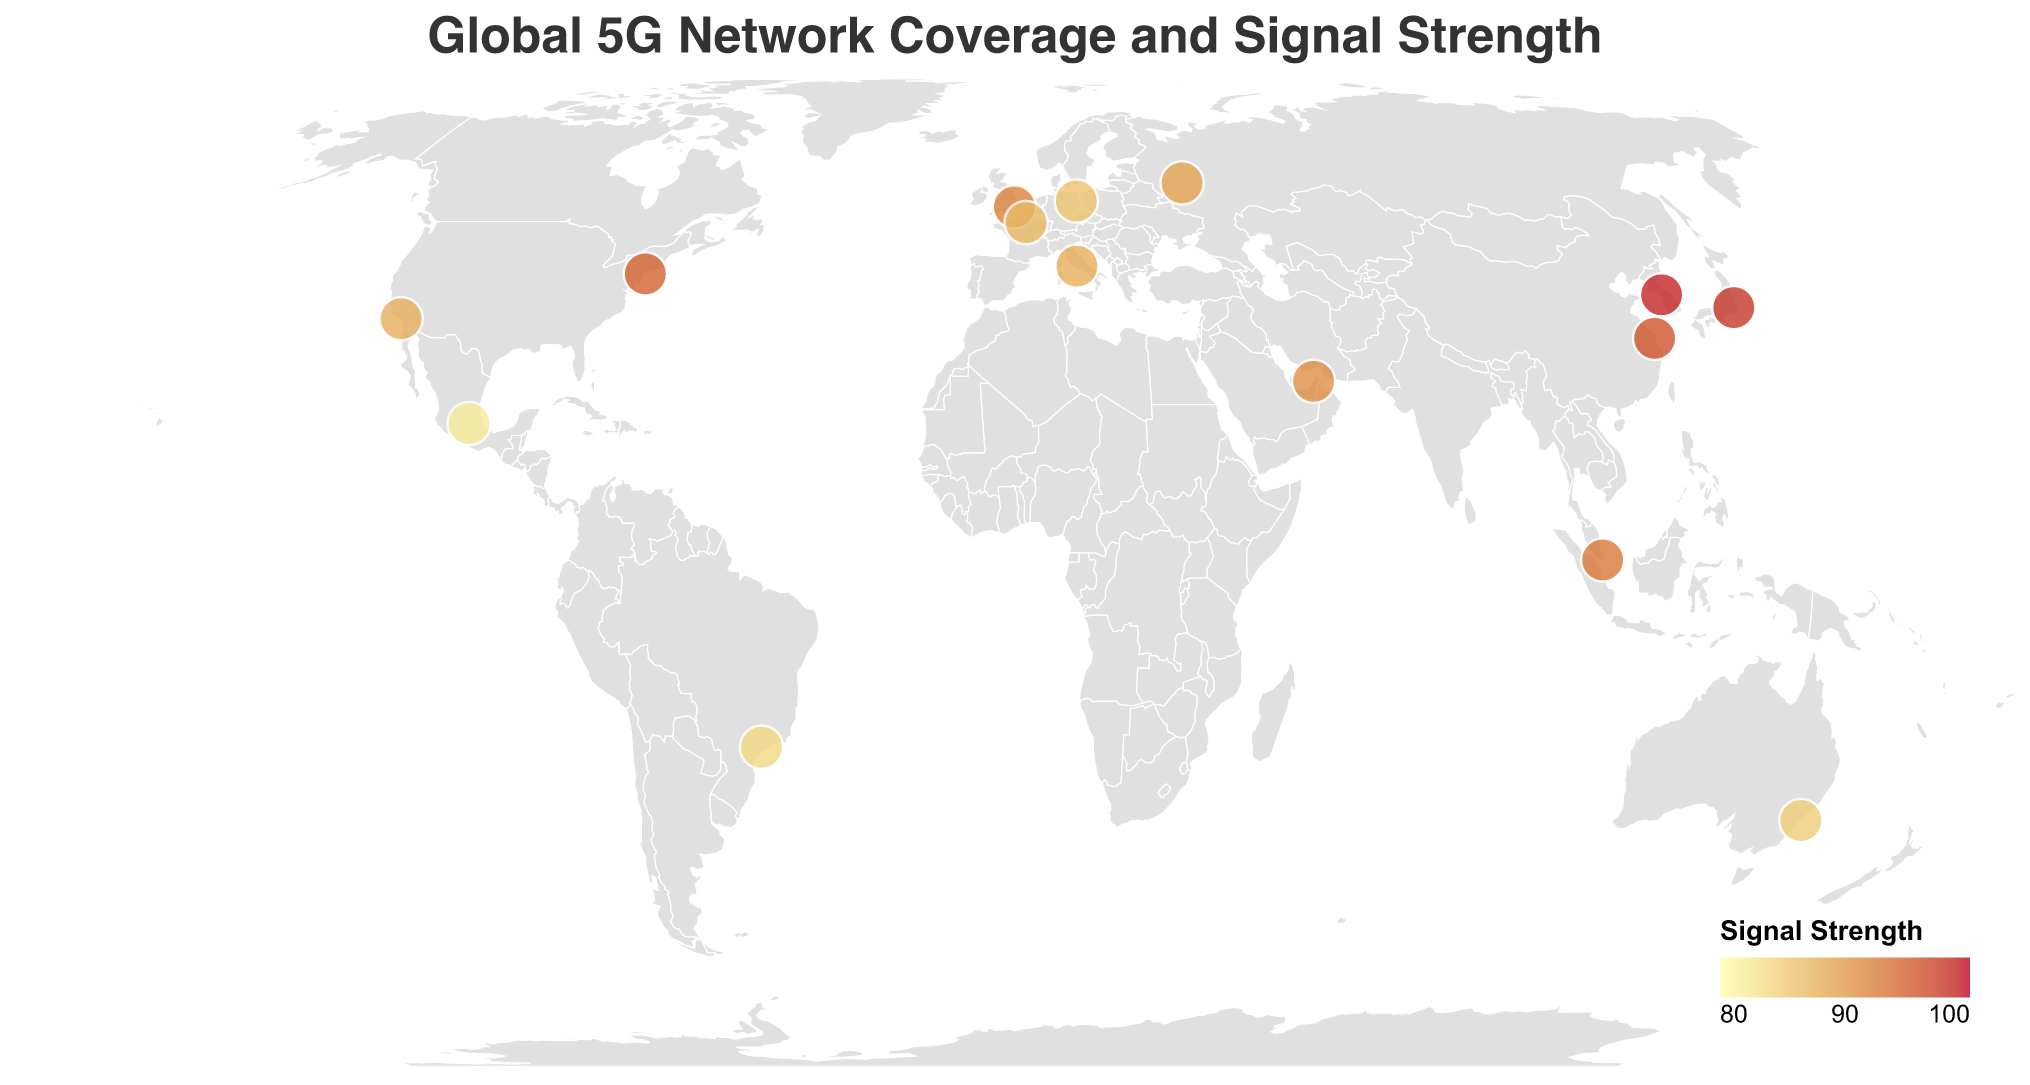What city has the highest 5G signal strength? The figure shows 5G signal strengths for various cities. By finding the city with the highest signal strength value on the color-coded circles, it's evident that Seoul, South Korea has the highest strength of 99.
Answer: Seoul Which country has a 5G signal strength of 91? By inspecting the color-coded circles and their corresponding tooltips, the country with a signal strength of 91 is identified as UAE, with the city being Dubai.
Answer: UAE How many cities have a signal strength above 90? By counting the number of circles that fall into the color range for signal strengths above 90, the cities are New York, London, Tokyo, Shanghai, Singapore, Dubai, and Seoul, making a total of 7 cities.
Answer: 7 What is the average signal strength of the cities in the USA? The cities in the USA are New York and Los Angeles with signal strengths of 95 and 88, respectively. The average signal strength is calculated as (95 + 88) / 2 = 91.5.
Answer: 91.5 Which continent has the highest average signal strength based on the cities shown? The continents represented in the figure are compared by averaging the signal strengths of the cities on each continent: 
- North America: (95 + 88 + 82) / 3 = 88.333
- Europe: (92 + 87 + 86 + 88) / 4 = 88.25
- Asia: (98 + 96 + 93 + 99 + 91) / 5 = 95.4
- Australia: 85
- South America: 84
Asia has the highest average signal strength.
Answer: Asia Is the signal strength in Berlin higher or lower than that in Rome? By referencing the color-coded circles and tooltips, Berlin's signal strength is 86 whereas Rome's signal strength is 88. Therefore, Berlin’s signal strength is lower.
Answer: Lower What is the color range used to represent the signal strengths? The color range observed in the heatmap scales from light yellow to dark red, representing the minimum signal strength of 80 to the maximum of 100, indicating a linear gradient of signal strengths.
Answer: Light yellow to dark red How does the signal strength in Sydney compare to that in Paris? Sydney has a signal strength of 85, whereas Paris has a signal strength of 87. Comparing these values shows that Paris has a higher signal strength than Sydney.
Answer: Paris is higher Which network operator has the strongest signal strength in the dataset and in which city? By analyzing the color-coded signal strengths and corresponding tooltips, the strongest signal strength of 99 is provided by SK Telecom in Seoul, South Korea.
Answer: SK Telecom in Seoul What is the median signal strength of the listed cities? To determine the median, the signal strengths are arranged in ascending order: 82, 84, 85, 86, 87, 88, 88, 89, 91, 92, 93, 95, 96, 98, 99. With 15 data points, the median is the 8th value, which is 89.
Answer: 89 